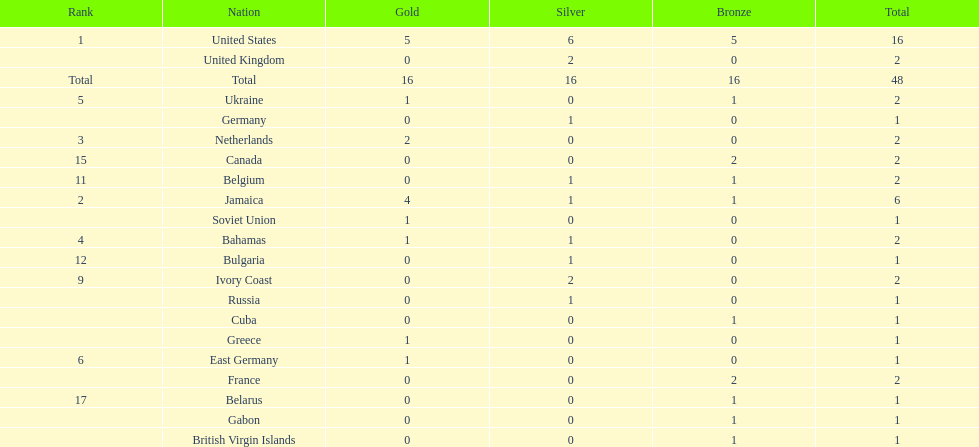What country won the most silver medals? United States. 